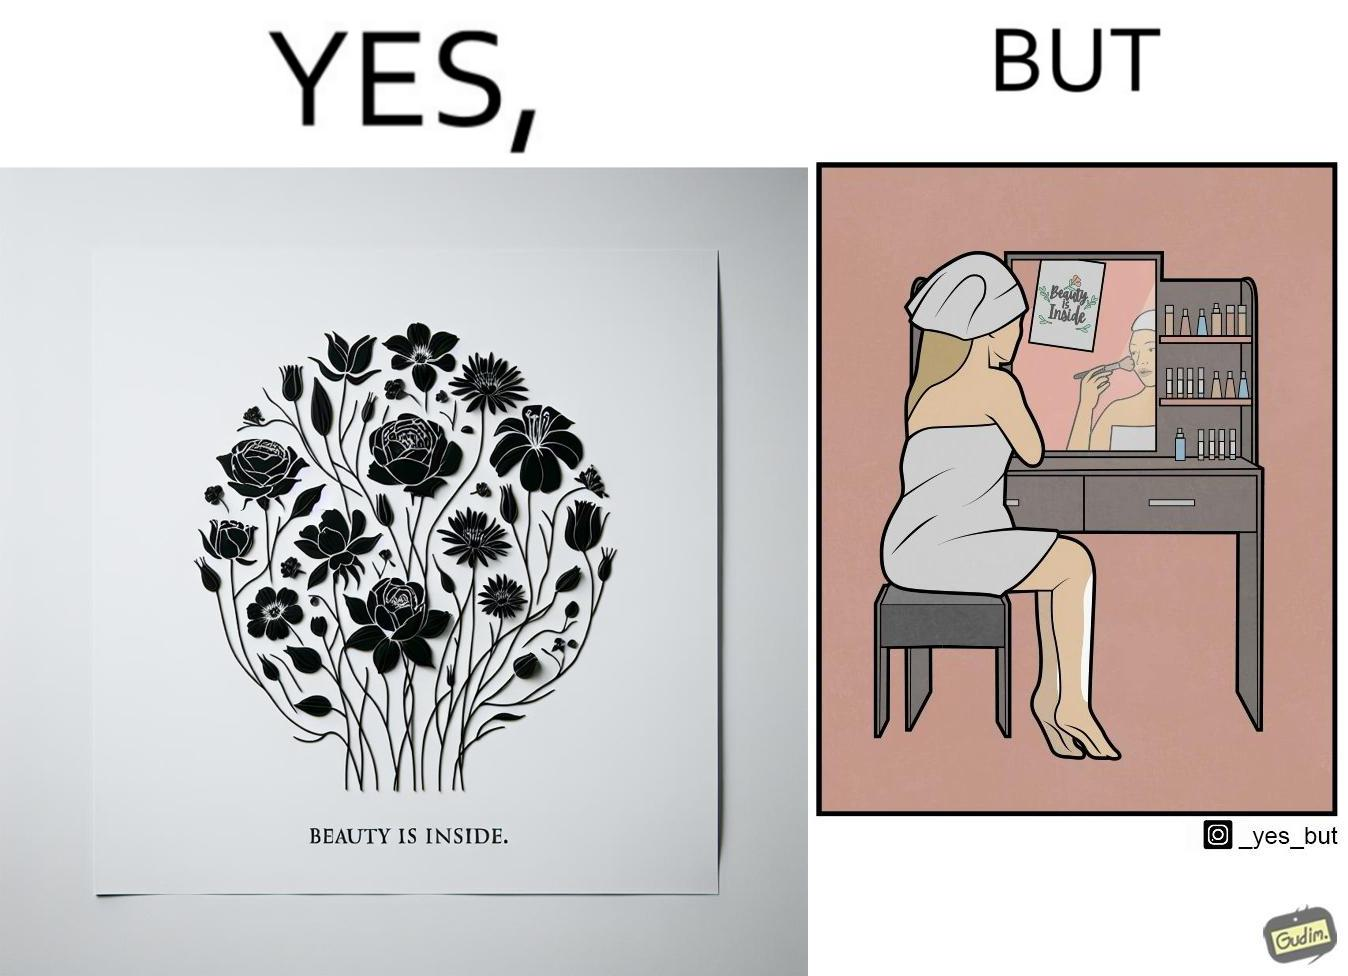What is shown in this image? The image is satirical because while the text on the paper says that beauty lies inside, the woman ignores the note and continues to apply makeup to improve her outer beauty. 